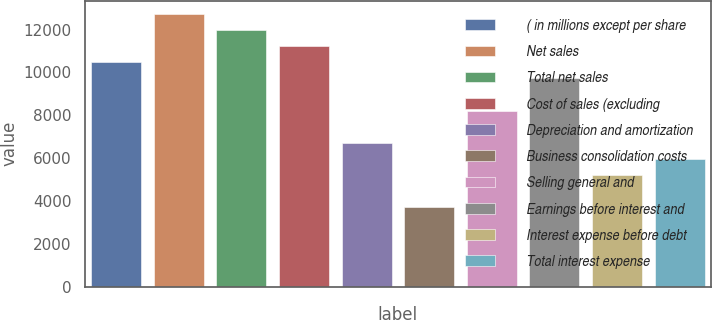<chart> <loc_0><loc_0><loc_500><loc_500><bar_chart><fcel>( in millions except per share<fcel>Net sales<fcel>Total net sales<fcel>Cost of sales (excluding<fcel>Depreciation and amortization<fcel>Business consolidation costs<fcel>Selling general and<fcel>Earnings before interest and<fcel>Interest expense before debt<fcel>Total interest expense<nl><fcel>10465.3<fcel>12707.7<fcel>11960.2<fcel>11212.8<fcel>6727.81<fcel>3737.85<fcel>8222.79<fcel>9717.77<fcel>5232.83<fcel>5980.32<nl></chart> 